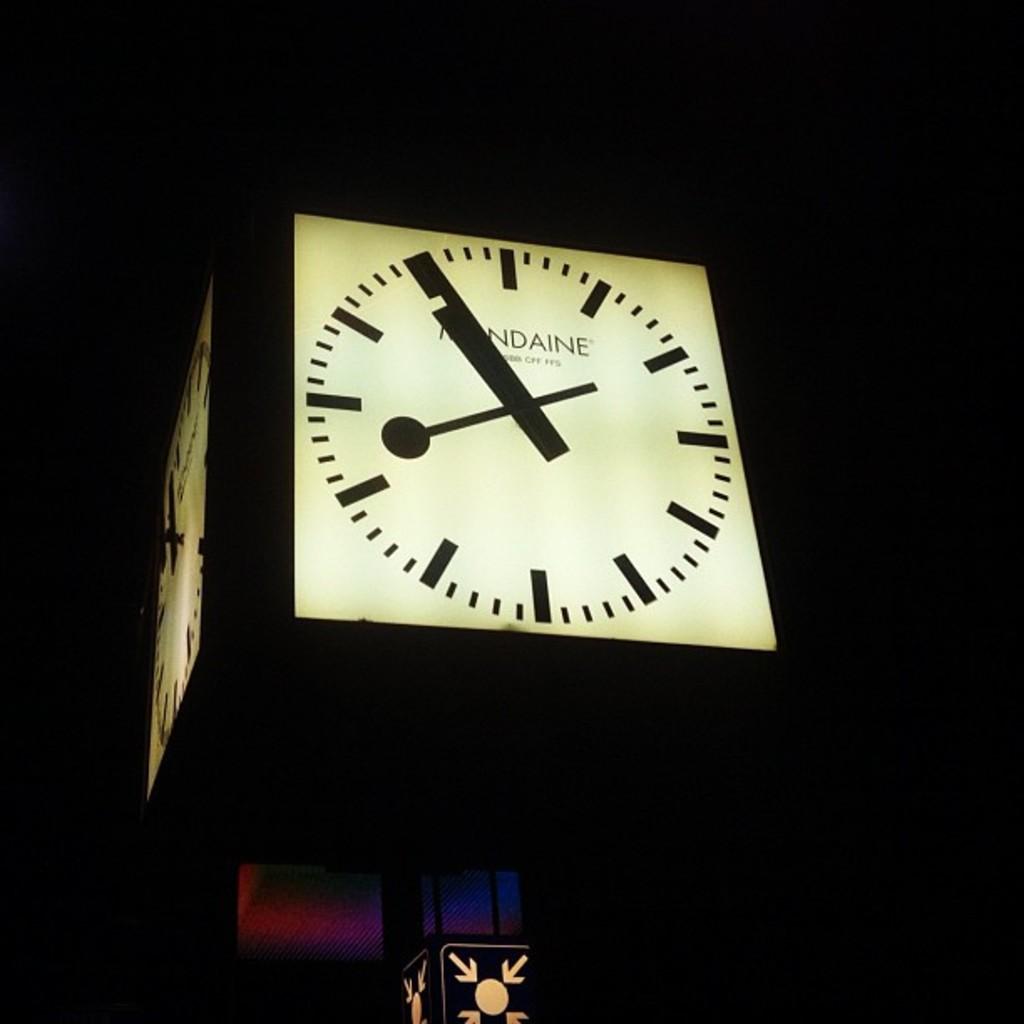What time does the clock read?
Offer a very short reply. 8:55. What letters do you see?
Offer a terse response. Ndaine. 